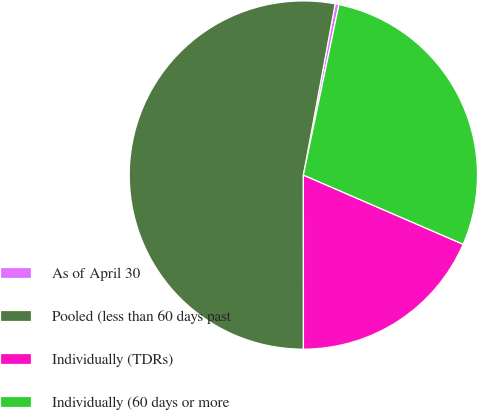Convert chart. <chart><loc_0><loc_0><loc_500><loc_500><pie_chart><fcel>As of April 30<fcel>Pooled (less than 60 days past<fcel>Individually (TDRs)<fcel>Individually (60 days or more<nl><fcel>0.35%<fcel>52.93%<fcel>18.49%<fcel>28.23%<nl></chart> 